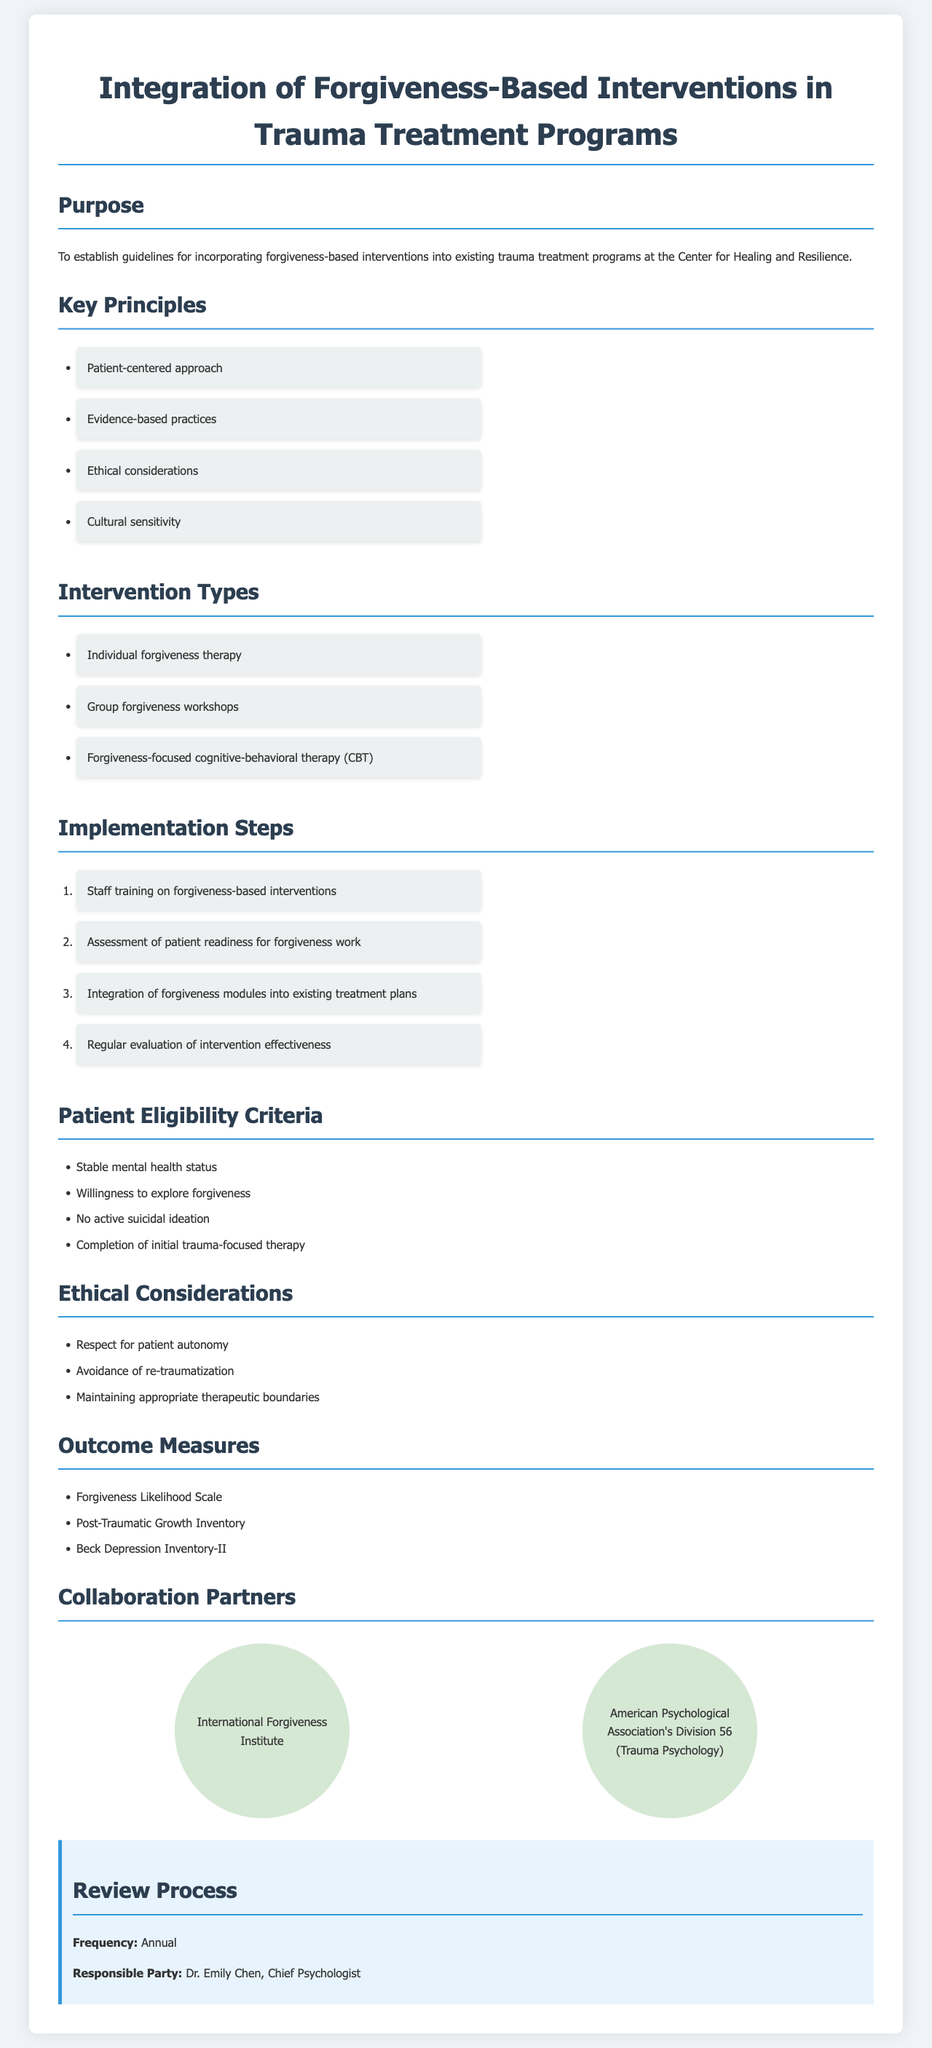What is the title of the document? The title is found at the top of the document as the main heading.
Answer: Integration of Forgiveness-Based Interventions in Trauma Treatment Programs Who is responsible for the review process? The document specifies the responsible party for the review process in the section dedicated to it.
Answer: Dr. Emily Chen What is one of the key principles outlined in the document? Key principles are listed in a bullet format, making it easy to retrieve specific items.
Answer: Patient-centered approach How often is the review process conducted? The frequency of the review process is clearly stated in the relevant section.
Answer: Annual What is the eligibility criterion related to mental health status? The document contains a list of eligibility criteria for patients.
Answer: Stable mental health status Which organization is mentioned as a collaboration partner? Collaboration partners are specified in a section, listing organizations involved.
Answer: International Forgiveness Institute Name an outcome measure listed in the document. Outcome measures are provided as a bullet list within the document.
Answer: Forgiveness Likelihood Scale What type of intervention involves group settings? The document describes various intervention types; one involves group interactions.
Answer: Group forgiveness workshops What is one ethical consideration mentioned? Ethical considerations are outlined in a bulleted format in the document for clarity.
Answer: Respect for patient autonomy 